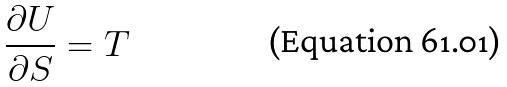Convert formula to latex. <formula><loc_0><loc_0><loc_500><loc_500>\frac { \partial U } { \partial S } = T</formula> 